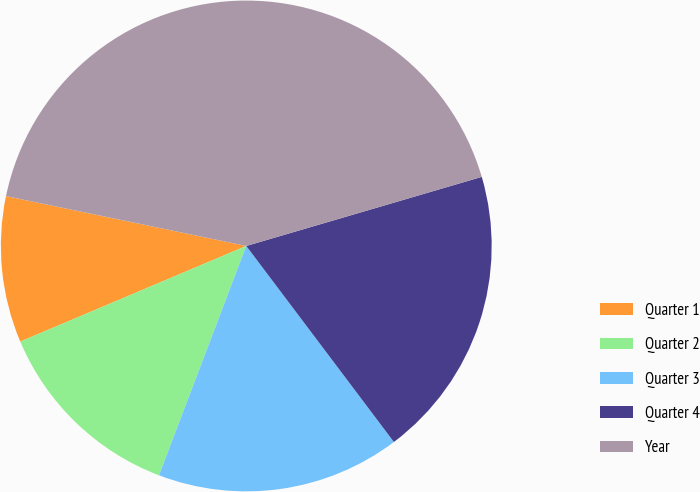Convert chart. <chart><loc_0><loc_0><loc_500><loc_500><pie_chart><fcel>Quarter 1<fcel>Quarter 2<fcel>Quarter 3<fcel>Quarter 4<fcel>Year<nl><fcel>9.63%<fcel>12.84%<fcel>16.06%<fcel>19.27%<fcel>42.2%<nl></chart> 